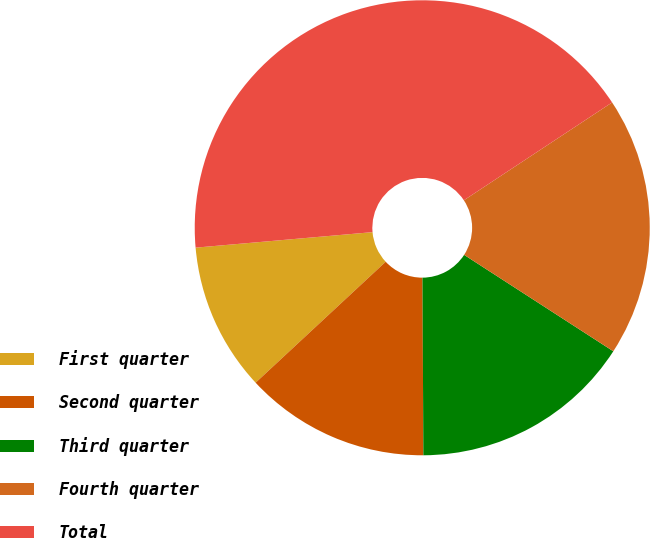Convert chart to OTSL. <chart><loc_0><loc_0><loc_500><loc_500><pie_chart><fcel>First quarter<fcel>Second quarter<fcel>Third quarter<fcel>Fourth quarter<fcel>Total<nl><fcel>10.53%<fcel>13.16%<fcel>15.79%<fcel>18.42%<fcel>42.11%<nl></chart> 